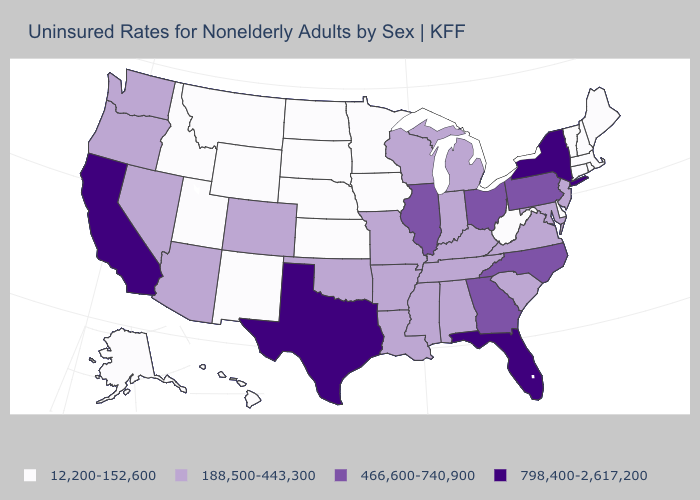What is the value of Wyoming?
Quick response, please. 12,200-152,600. Name the states that have a value in the range 12,200-152,600?
Short answer required. Alaska, Connecticut, Delaware, Hawaii, Idaho, Iowa, Kansas, Maine, Massachusetts, Minnesota, Montana, Nebraska, New Hampshire, New Mexico, North Dakota, Rhode Island, South Dakota, Utah, Vermont, West Virginia, Wyoming. Among the states that border Florida , which have the lowest value?
Be succinct. Alabama. Does North Carolina have the same value as Pennsylvania?
Answer briefly. Yes. Does the map have missing data?
Concise answer only. No. What is the value of Iowa?
Keep it brief. 12,200-152,600. Name the states that have a value in the range 466,600-740,900?
Be succinct. Georgia, Illinois, North Carolina, Ohio, Pennsylvania. Name the states that have a value in the range 798,400-2,617,200?
Quick response, please. California, Florida, New York, Texas. Does Alaska have the lowest value in the USA?
Keep it brief. Yes. Among the states that border Wisconsin , which have the highest value?
Be succinct. Illinois. Name the states that have a value in the range 12,200-152,600?
Short answer required. Alaska, Connecticut, Delaware, Hawaii, Idaho, Iowa, Kansas, Maine, Massachusetts, Minnesota, Montana, Nebraska, New Hampshire, New Mexico, North Dakota, Rhode Island, South Dakota, Utah, Vermont, West Virginia, Wyoming. Among the states that border Florida , does Georgia have the lowest value?
Concise answer only. No. What is the lowest value in states that border New Hampshire?
Concise answer only. 12,200-152,600. Does Vermont have a lower value than New York?
Give a very brief answer. Yes. Which states have the highest value in the USA?
Short answer required. California, Florida, New York, Texas. 